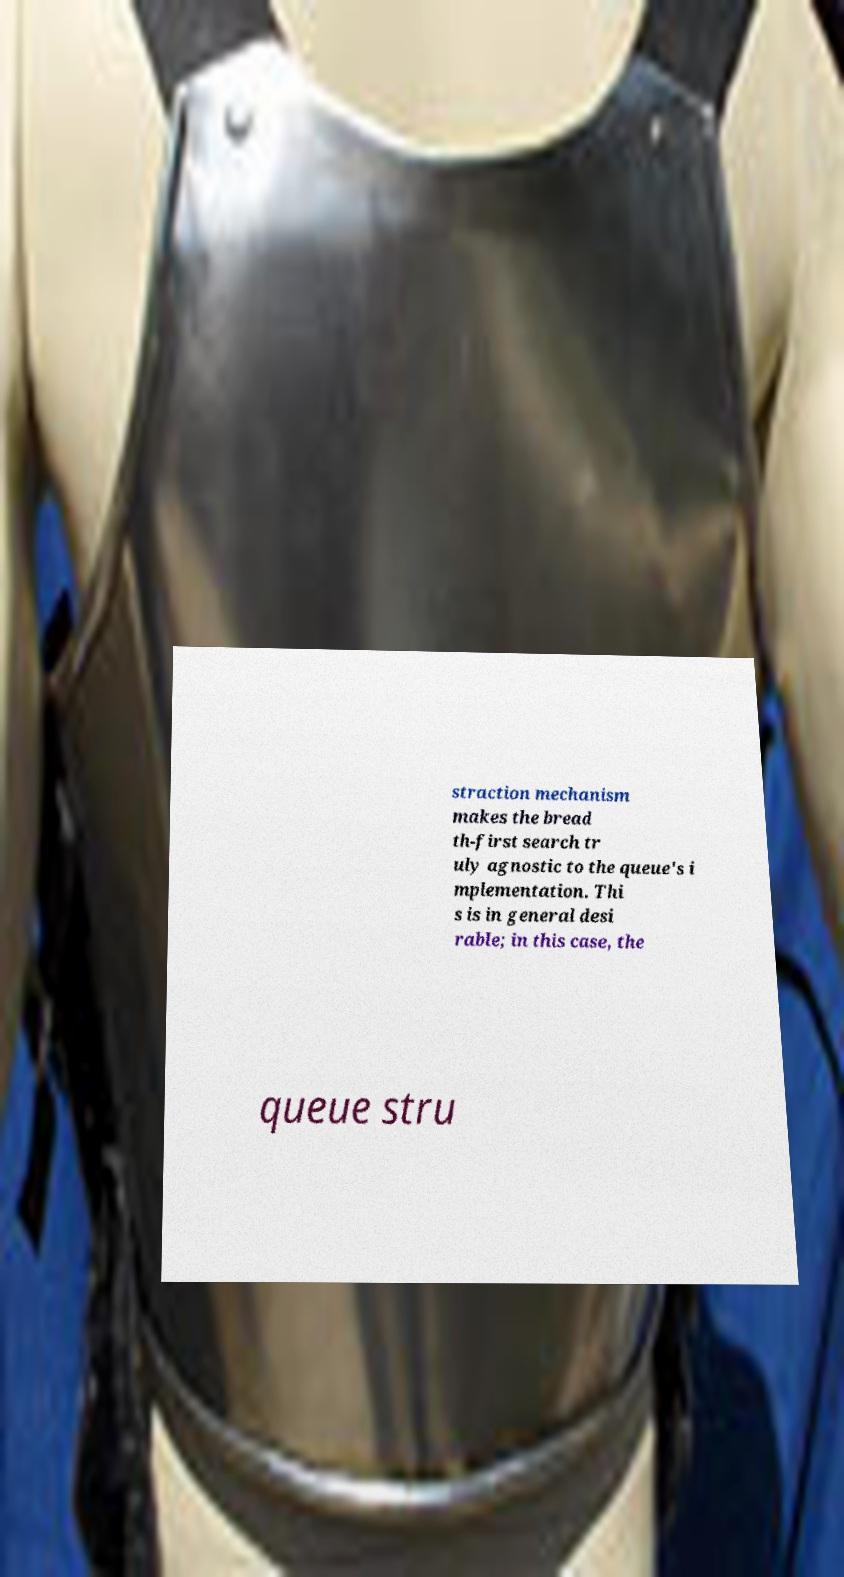There's text embedded in this image that I need extracted. Can you transcribe it verbatim? straction mechanism makes the bread th-first search tr uly agnostic to the queue's i mplementation. Thi s is in general desi rable; in this case, the queue stru 